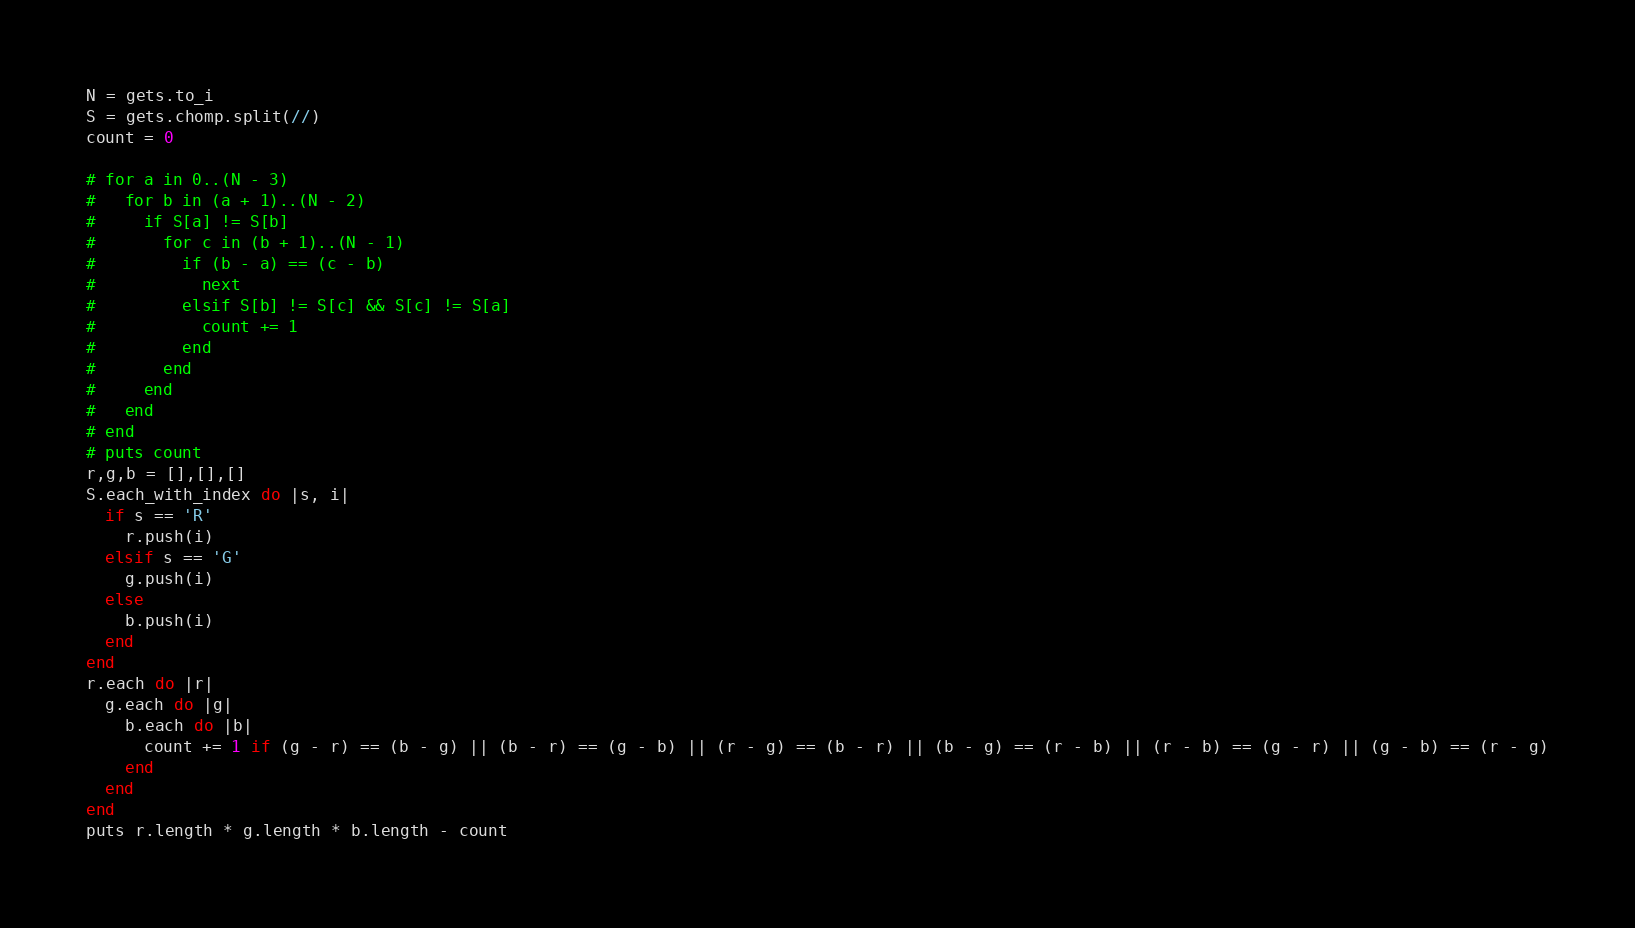Convert code to text. <code><loc_0><loc_0><loc_500><loc_500><_Ruby_>N = gets.to_i
S = gets.chomp.split(//)
count = 0

# for a in 0..(N - 3)
#   for b in (a + 1)..(N - 2)
#     if S[a] != S[b]
#       for c in (b + 1)..(N - 1)
#         if (b - a) == (c - b)
#           next
#         elsif S[b] != S[c] && S[c] != S[a]
#           count += 1
#         end
#       end
#     end
#   end
# end
# puts count
r,g,b = [],[],[]
S.each_with_index do |s, i|
  if s == 'R'
    r.push(i)
  elsif s == 'G'
    g.push(i)
  else
    b.push(i)
  end
end
r.each do |r|
  g.each do |g|
    b.each do |b|
      count += 1 if (g - r) == (b - g) || (b - r) == (g - b) || (r - g) == (b - r) || (b - g) == (r - b) || (r - b) == (g - r) || (g - b) == (r - g)
    end
  end
end
puts r.length * g.length * b.length - count
</code> 